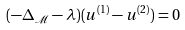Convert formula to latex. <formula><loc_0><loc_0><loc_500><loc_500>( - \Delta _ { \mathcal { M } } - \lambda ) ( u ^ { ( 1 ) } - u ^ { ( 2 ) } ) = 0</formula> 